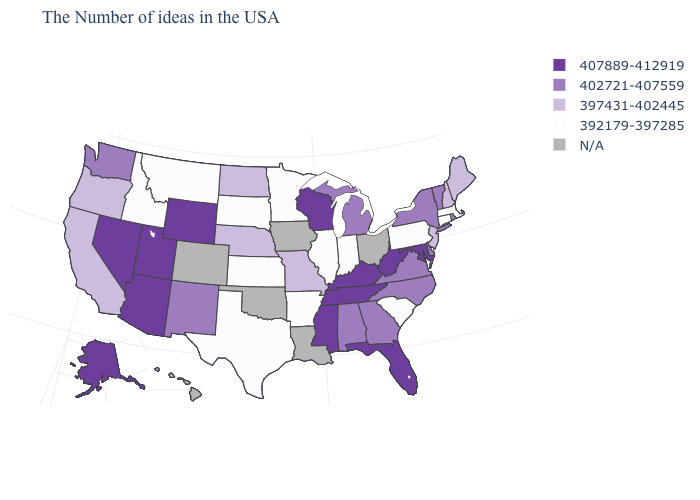What is the highest value in the USA?
Give a very brief answer. 407889-412919. Among the states that border Oregon , which have the highest value?
Short answer required. Nevada. Name the states that have a value in the range 397431-402445?
Be succinct. Maine, New Hampshire, New Jersey, Missouri, Nebraska, North Dakota, California, Oregon. Among the states that border Illinois , which have the lowest value?
Give a very brief answer. Indiana. Among the states that border Ohio , which have the lowest value?
Give a very brief answer. Pennsylvania, Indiana. Name the states that have a value in the range 392179-397285?
Concise answer only. Massachusetts, Connecticut, Pennsylvania, South Carolina, Indiana, Illinois, Arkansas, Minnesota, Kansas, Texas, South Dakota, Montana, Idaho. Name the states that have a value in the range 392179-397285?
Concise answer only. Massachusetts, Connecticut, Pennsylvania, South Carolina, Indiana, Illinois, Arkansas, Minnesota, Kansas, Texas, South Dakota, Montana, Idaho. Among the states that border Rhode Island , which have the highest value?
Answer briefly. Massachusetts, Connecticut. How many symbols are there in the legend?
Quick response, please. 5. Name the states that have a value in the range 407889-412919?
Give a very brief answer. Maryland, West Virginia, Florida, Kentucky, Tennessee, Wisconsin, Mississippi, Wyoming, Utah, Arizona, Nevada, Alaska. Does Kansas have the highest value in the MidWest?
Keep it brief. No. What is the lowest value in the USA?
Quick response, please. 392179-397285. Name the states that have a value in the range 397431-402445?
Give a very brief answer. Maine, New Hampshire, New Jersey, Missouri, Nebraska, North Dakota, California, Oregon. 